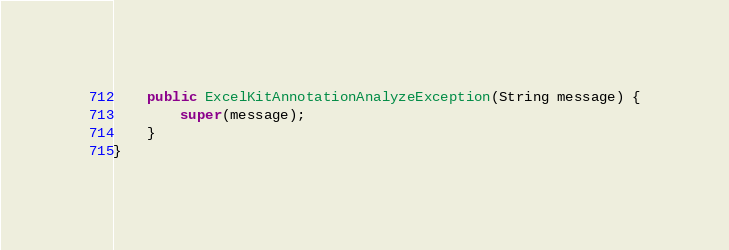Convert code to text. <code><loc_0><loc_0><loc_500><loc_500><_Java_>    public ExcelKitAnnotationAnalyzeException(String message) {
        super(message);
    }
}
</code> 